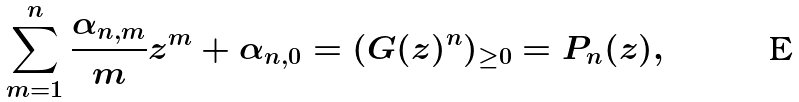Convert formula to latex. <formula><loc_0><loc_0><loc_500><loc_500>\sum _ { m = 1 } ^ { n } \frac { \alpha _ { n , m } } { m } z ^ { m } + \alpha _ { n , 0 } = ( G ( z ) ^ { n } ) _ { \geq 0 } = P _ { n } ( z ) ,</formula> 